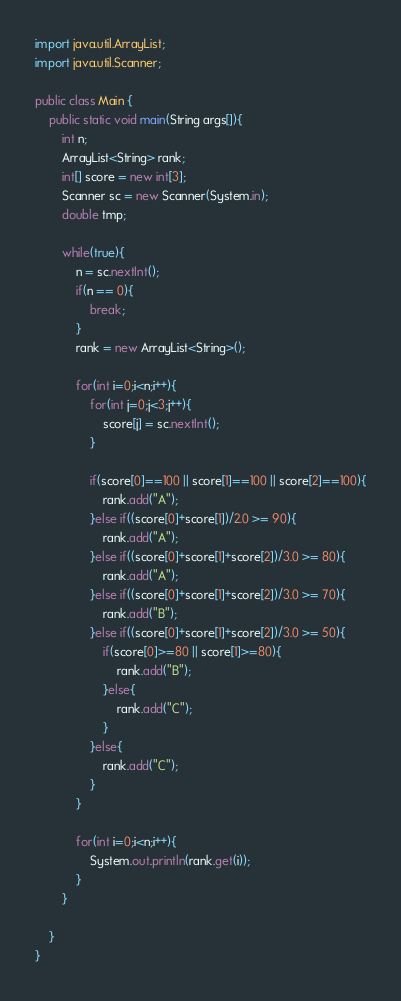<code> <loc_0><loc_0><loc_500><loc_500><_Java_>import java.util.ArrayList;
import java.util.Scanner;

public class Main {
	public static void main(String args[]){
		int n;
		ArrayList<String> rank;
		int[] score = new int[3];
		Scanner sc = new Scanner(System.in);
		double tmp;
		
		while(true){
			n = sc.nextInt();
			if(n == 0){
				break;
			}
			rank = new ArrayList<String>();
			
			for(int i=0;i<n;i++){
				for(int j=0;j<3;j++){
					score[j] = sc.nextInt();
				}
				
				if(score[0]==100 || score[1]==100 || score[2]==100){
					rank.add("A");
				}else if((score[0]+score[1])/2.0 >= 90){
					rank.add("A");
				}else if((score[0]+score[1]+score[2])/3.0 >= 80){
					rank.add("A");
				}else if((score[0]+score[1]+score[2])/3.0 >= 70){
					rank.add("B");
				}else if((score[0]+score[1]+score[2])/3.0 >= 50){
					if(score[0]>=80 || score[1]>=80){
						rank.add("B");
					}else{
						rank.add("C");
					}
				}else{
					rank.add("C");
				}
			}
			
			for(int i=0;i<n;i++){
				System.out.println(rank.get(i));
			}
		}
		
	}
}</code> 